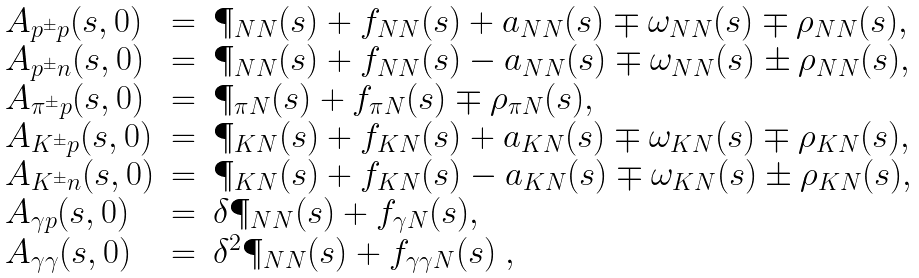<formula> <loc_0><loc_0><loc_500><loc_500>\begin{array} { l c l } A _ { p ^ { \pm } p } ( s , 0 ) & = & \P _ { N N } ( s ) + f _ { N N } ( s ) + a _ { N N } ( s ) \mp \omega _ { N N } ( s ) \mp \rho _ { N N } ( s ) , \\ A _ { p ^ { \pm } n } ( s , 0 ) & = & \P _ { N N } ( s ) + f _ { N N } ( s ) - a _ { N N } ( s ) \mp \omega _ { N N } ( s ) \pm \rho _ { N N } ( s ) , \\ A _ { \pi ^ { \pm } p } ( s , 0 ) & = & \P _ { \pi N } ( s ) + f _ { \pi N } ( s ) \mp \rho _ { \pi N } ( s ) , \\ A _ { K ^ { \pm } p } ( s , 0 ) & = & \P _ { K N } ( s ) + f _ { K N } ( s ) + a _ { K N } ( s ) \mp \omega _ { K N } ( s ) \mp \rho _ { K N } ( s ) , \\ A _ { K ^ { \pm } n } ( s , 0 ) & = & \P _ { K N } ( s ) + f _ { K N } ( s ) - a _ { K N } ( s ) \mp \omega _ { K N } ( s ) \pm \rho _ { K N } ( s ) , \\ A _ { \gamma p } ( s , 0 ) & = & \delta \P _ { N N } ( s ) + f _ { \gamma N } ( s ) , \\ A _ { \gamma \gamma } ( s , 0 ) & = & \delta ^ { 2 } \P _ { N N } ( s ) + f _ { \gamma \gamma N } ( s ) \ , \\ \end{array}</formula> 